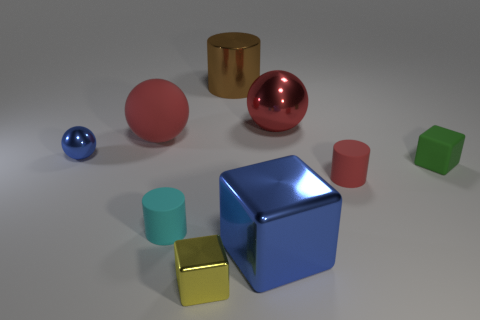Are any small shiny balls visible?
Offer a very short reply. Yes. The red rubber object in front of the matte object behind the tiny cube behind the yellow block is what shape?
Provide a short and direct response. Cylinder. There is a big metal cube; how many rubber spheres are on the right side of it?
Make the answer very short. 0. Do the cube to the left of the brown cylinder and the green object have the same material?
Make the answer very short. No. What number of other objects are there of the same shape as the yellow shiny thing?
Offer a terse response. 2. There is a tiny shiny thing that is behind the matte cylinder that is to the left of the red metal thing; how many big blue things are behind it?
Make the answer very short. 0. What color is the small shiny object in front of the green object?
Your answer should be compact. Yellow. Does the large metallic thing that is in front of the red shiny sphere have the same color as the tiny matte cube?
Offer a very short reply. No. There is a red object that is the same shape as the large brown shiny object; what size is it?
Make the answer very short. Small. Is there anything else that is the same size as the cyan matte cylinder?
Your answer should be very brief. Yes. 